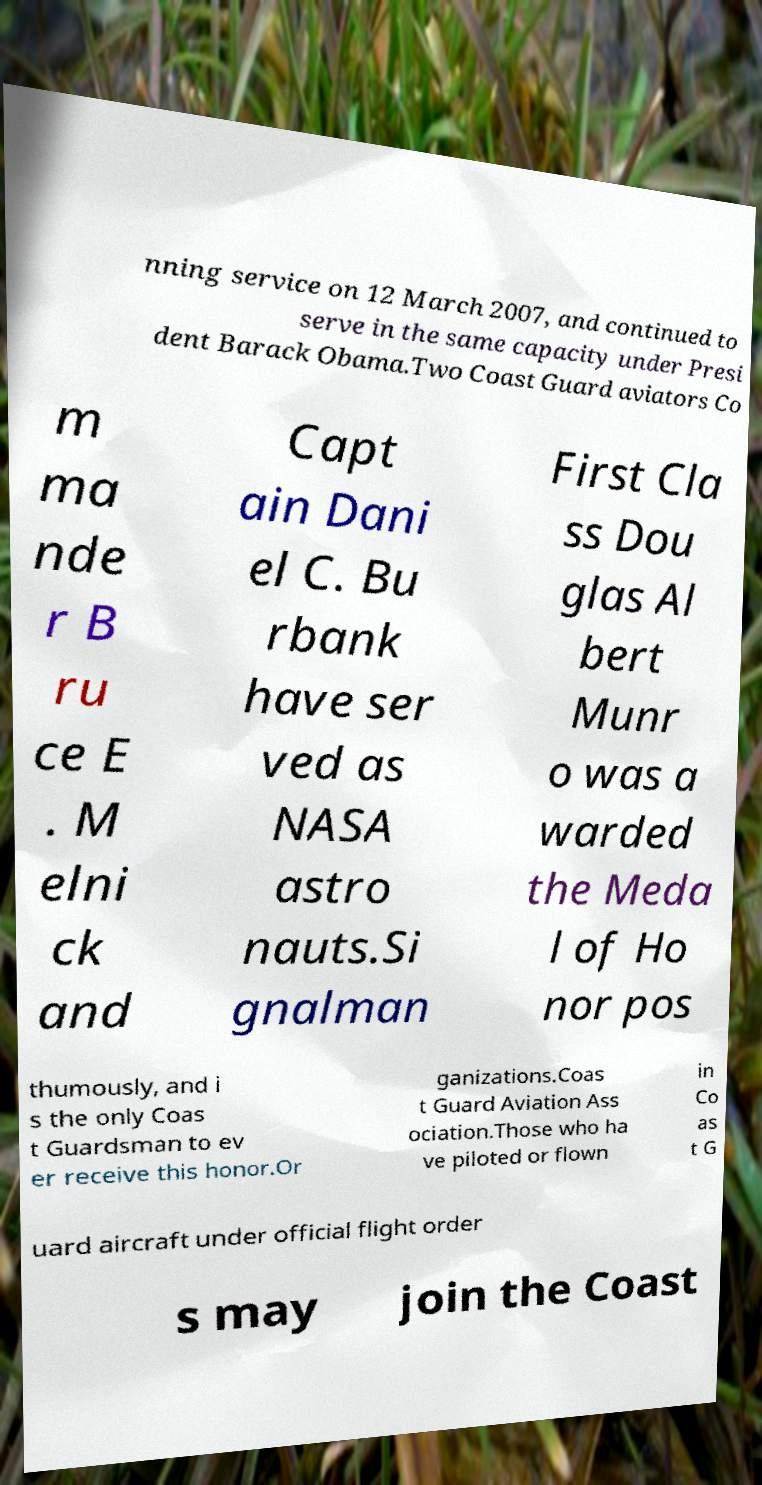Could you assist in decoding the text presented in this image and type it out clearly? nning service on 12 March 2007, and continued to serve in the same capacity under Presi dent Barack Obama.Two Coast Guard aviators Co m ma nde r B ru ce E . M elni ck and Capt ain Dani el C. Bu rbank have ser ved as NASA astro nauts.Si gnalman First Cla ss Dou glas Al bert Munr o was a warded the Meda l of Ho nor pos thumously, and i s the only Coas t Guardsman to ev er receive this honor.Or ganizations.Coas t Guard Aviation Ass ociation.Those who ha ve piloted or flown in Co as t G uard aircraft under official flight order s may join the Coast 